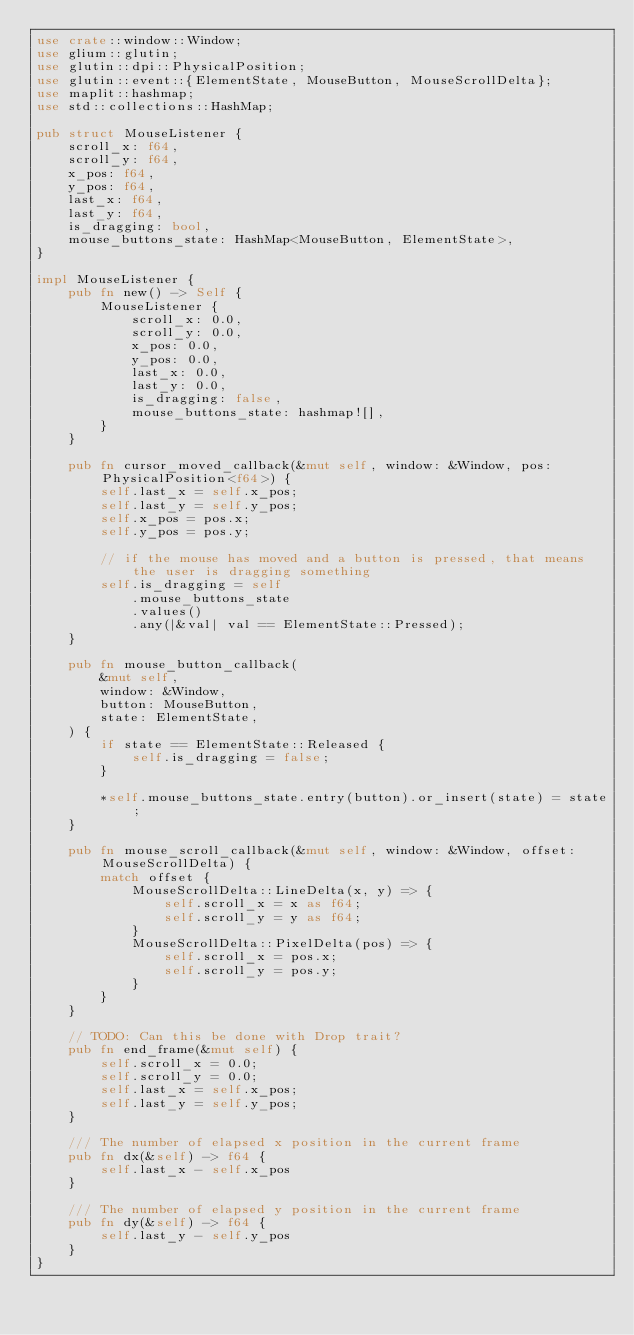<code> <loc_0><loc_0><loc_500><loc_500><_Rust_>use crate::window::Window;
use glium::glutin;
use glutin::dpi::PhysicalPosition;
use glutin::event::{ElementState, MouseButton, MouseScrollDelta};
use maplit::hashmap;
use std::collections::HashMap;

pub struct MouseListener {
    scroll_x: f64,
    scroll_y: f64,
    x_pos: f64,
    y_pos: f64,
    last_x: f64,
    last_y: f64,
    is_dragging: bool,
    mouse_buttons_state: HashMap<MouseButton, ElementState>,
}

impl MouseListener {
    pub fn new() -> Self {
        MouseListener {
            scroll_x: 0.0,
            scroll_y: 0.0,
            x_pos: 0.0,
            y_pos: 0.0,
            last_x: 0.0,
            last_y: 0.0,
            is_dragging: false,
            mouse_buttons_state: hashmap![],
        }
    }

    pub fn cursor_moved_callback(&mut self, window: &Window, pos: PhysicalPosition<f64>) {
        self.last_x = self.x_pos;
        self.last_y = self.y_pos;
        self.x_pos = pos.x;
        self.y_pos = pos.y;

        // if the mouse has moved and a button is pressed, that means the user is dragging something
        self.is_dragging = self
            .mouse_buttons_state
            .values()
            .any(|&val| val == ElementState::Pressed);
    }

    pub fn mouse_button_callback(
        &mut self,
        window: &Window,
        button: MouseButton,
        state: ElementState,
    ) {
        if state == ElementState::Released {
            self.is_dragging = false;
        }

        *self.mouse_buttons_state.entry(button).or_insert(state) = state;
    }

    pub fn mouse_scroll_callback(&mut self, window: &Window, offset: MouseScrollDelta) {
        match offset {
            MouseScrollDelta::LineDelta(x, y) => {
                self.scroll_x = x as f64;
                self.scroll_y = y as f64;
            }
            MouseScrollDelta::PixelDelta(pos) => {
                self.scroll_x = pos.x;
                self.scroll_y = pos.y;
            }
        }
    }

    // TODO: Can this be done with Drop trait?
    pub fn end_frame(&mut self) {
        self.scroll_x = 0.0;
        self.scroll_y = 0.0;
        self.last_x = self.x_pos;
        self.last_y = self.y_pos;
    }

    /// The number of elapsed x position in the current frame
    pub fn dx(&self) -> f64 {
        self.last_x - self.x_pos
    }

    /// The number of elapsed y position in the current frame
    pub fn dy(&self) -> f64 {
        self.last_y - self.y_pos
    }
}
</code> 